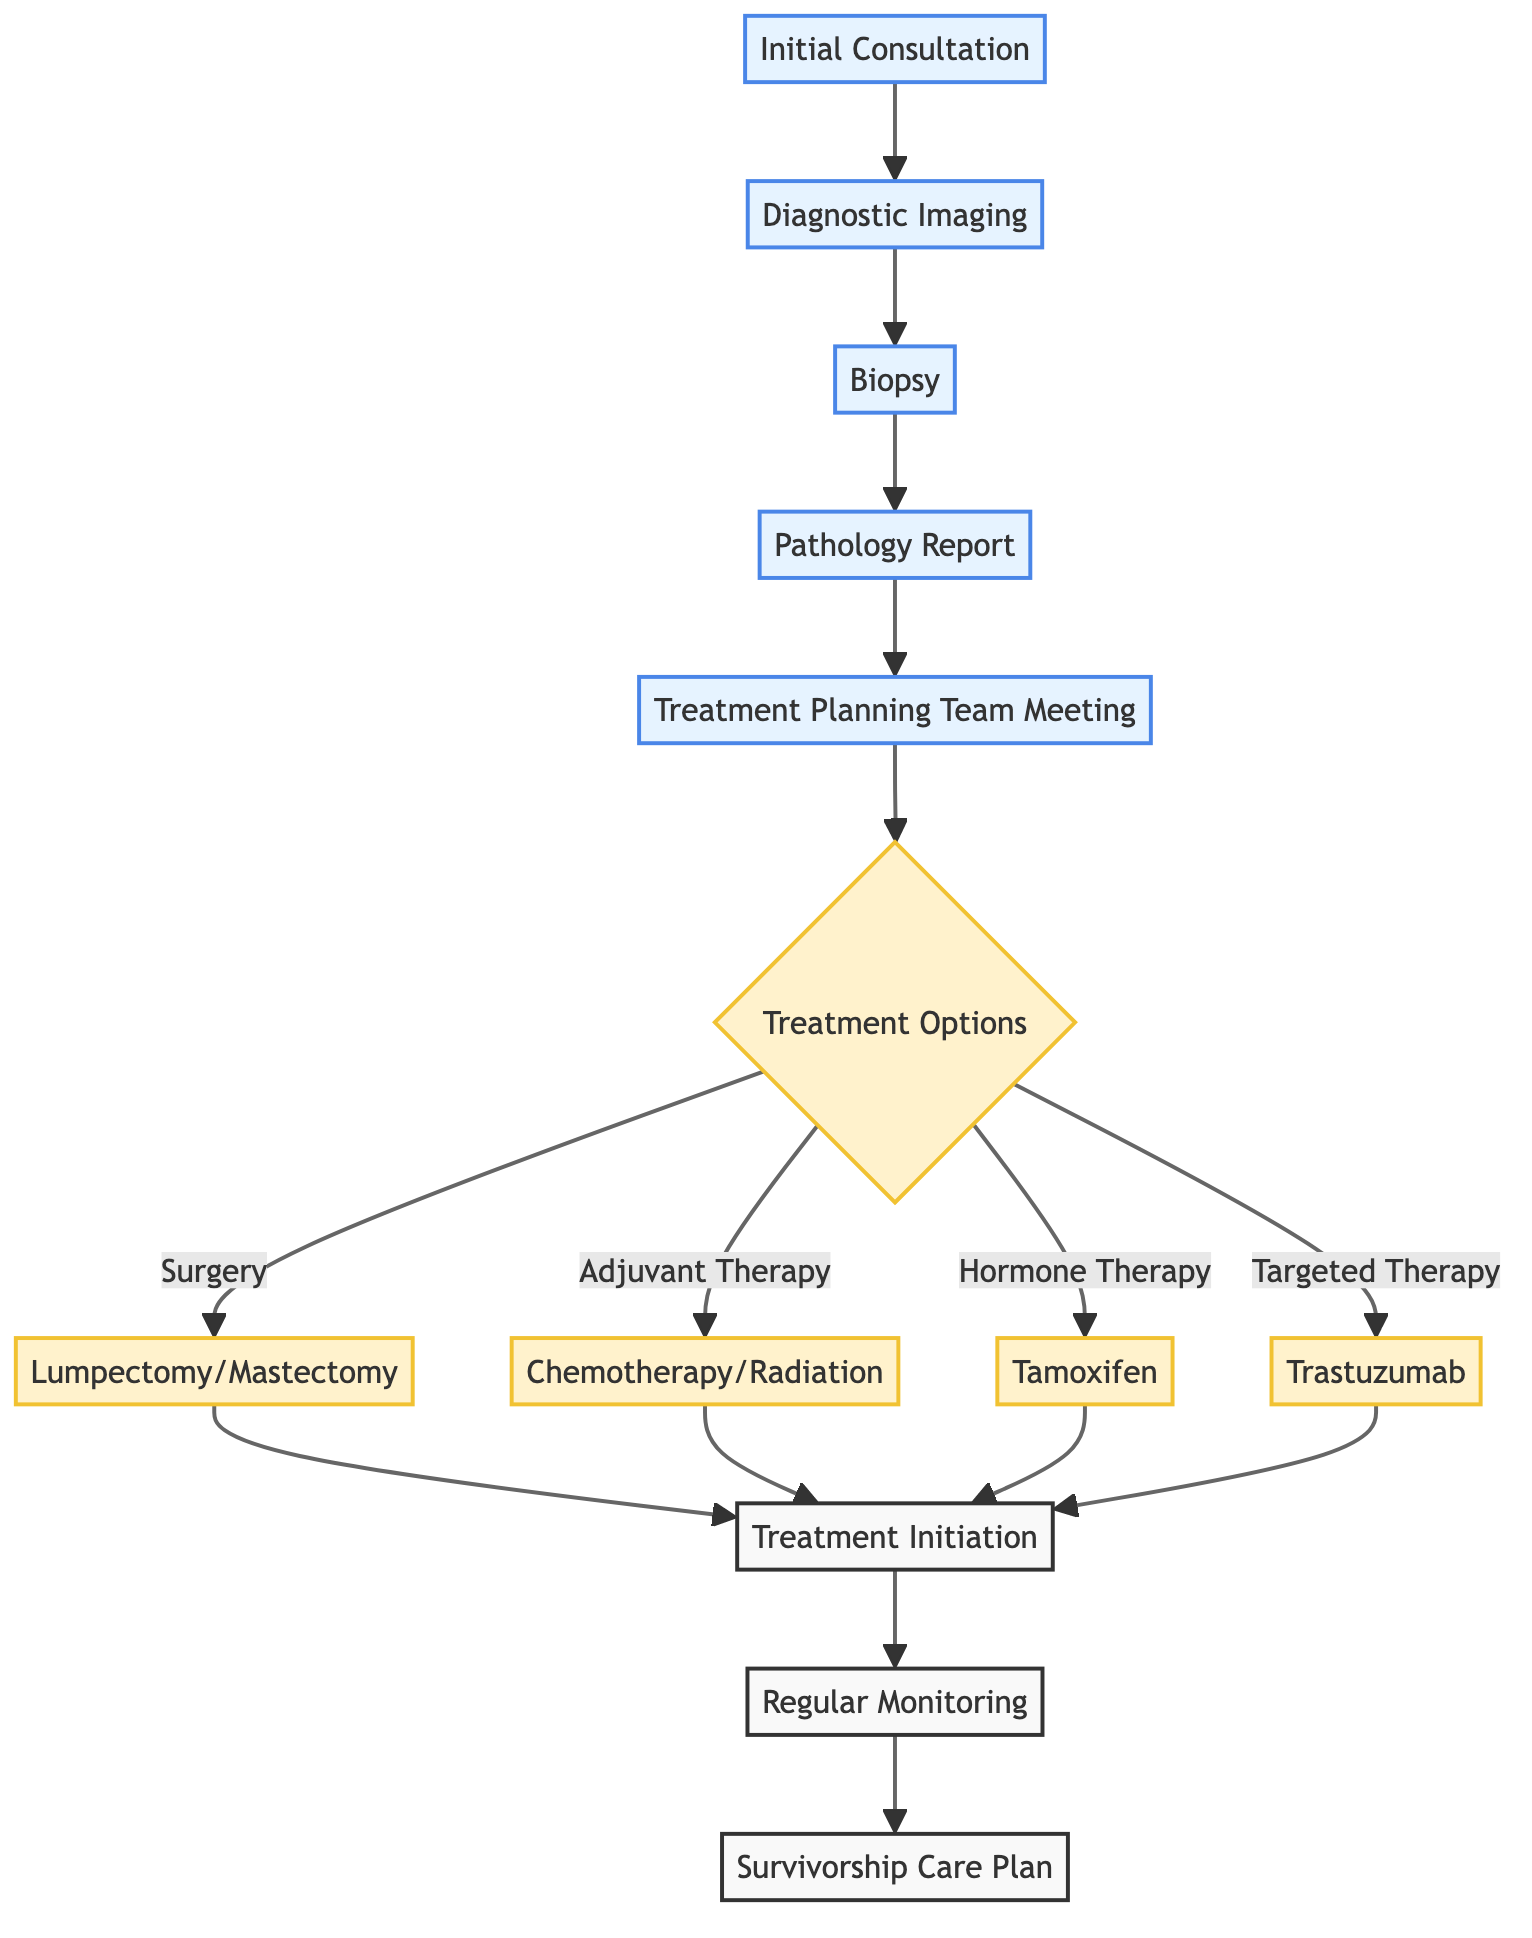What is the first step in the treatment pathway? The first step is the "Initial Consultation," where the patient meets with the oncologist to discuss symptoms and medical history.
Answer: Initial Consultation How many treatment options are listed in the pathway? There are four main types of treatment options listed: Surgery, Adjuvant Therapy, Hormone Therapy, and Targeted Therapy.
Answer: 4 What follows the "Pathology Report"? After the "Pathology Report," the next step is the "Treatment Planning Team Meeting," where various specialists come together to discuss the patient's care.
Answer: Treatment Planning Team Meeting Which type of therapy involves Tamoxifen? The type of therapy that involves Tamoxifen is "Hormone Therapy."
Answer: Hormone Therapy What is the last step of the pathway? The last step in the pathway is the "Survivorship Care Plan," which focuses on developing a long-term care plan for the patient.
Answer: Survivorship Care Plan Which node connects the treatment options to the initiation of treatment? The node that connects the treatment options to the initiation of treatment is "Treatment Initiation."
Answer: Treatment Initiation How many diagnostic imaging methods are mentioned before the biopsy? Three diagnostic imaging methods are mentioned: Mammogram, Ultrasound, and MRI.
Answer: 3 Which specialists are included in the treatment planning team? The specialists included in the treatment planning team are Oncologist, Radiologist, Surgeon, Pathologist, and Nurse Navigator.
Answer: Oncologist, Radiologist, Surgeon, Pathologist, Nurse Navigator What kind of therapy is Trastuzumab associated with? Trastuzumab is associated with "Targeted Therapy."
Answer: Targeted Therapy 